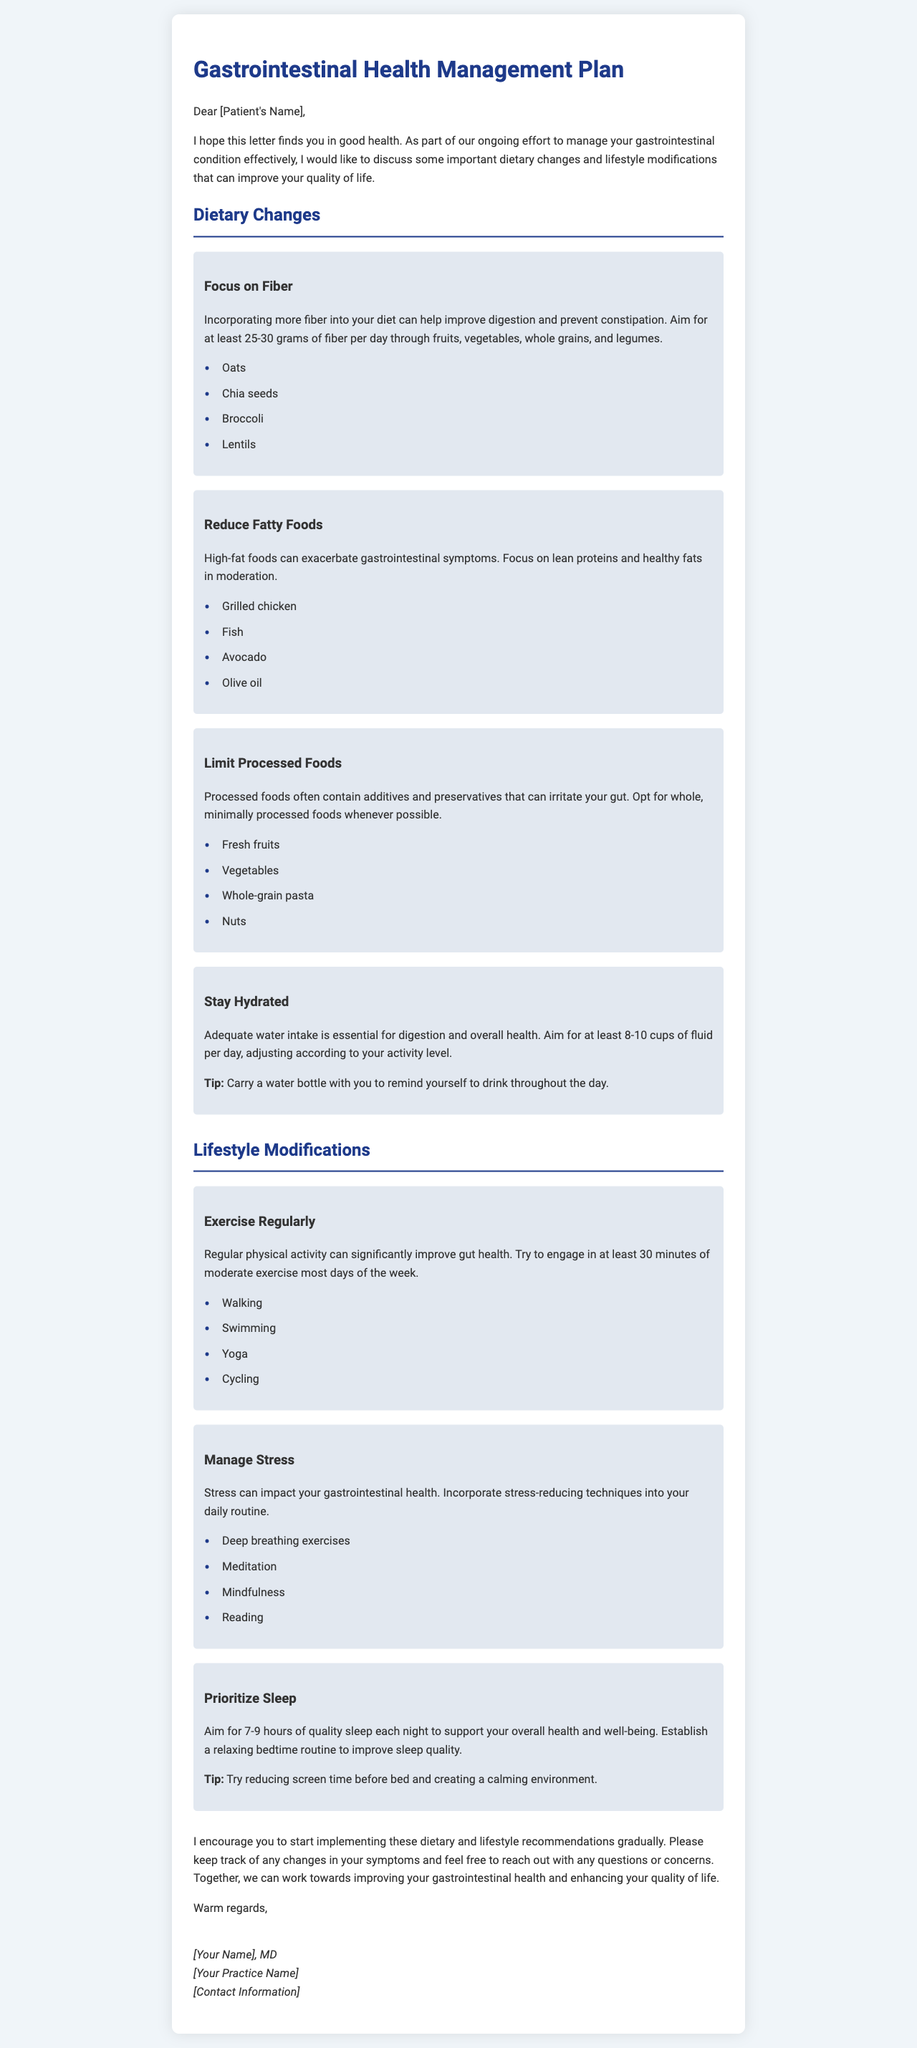What is the main focus of the dietary changes outlined? The main focus of the dietary changes is to improve digestion and prevent constipation by incorporating more fiber.
Answer: Fiber How many grams of fiber should a patient aim for daily? The letter specifies that patients should aim for at least 25-30 grams of fiber per day.
Answer: 25-30 grams Which food is recommended for hydration? The letter suggests carrying a water bottle to remind patients to drink throughout the day.
Answer: Water What type of exercise is suggested for improving gut health? The document recommends engaging in at least 30 minutes of moderate exercise, including activities like walking and swimming.
Answer: Moderate exercise What is one stress-reducing technique mentioned? The letter lists deep breathing exercises as one of the techniques to manage stress.
Answer: Deep breathing exercises How many hours of sleep should a patient aim for each night? The letter advises patients to aim for 7-9 hours of quality sleep each night.
Answer: 7-9 hours Who is the author of the letter? The letter will be signed by the author, typically a medical doctor, whose name is placeholdered in the letter.
Answer: [Your Name] What is the purpose of the letter? The purpose is to outline dietary changes and lifestyle modifications to manage gastrointestinal health effectively.
Answer: Manage gastrointestinal health 